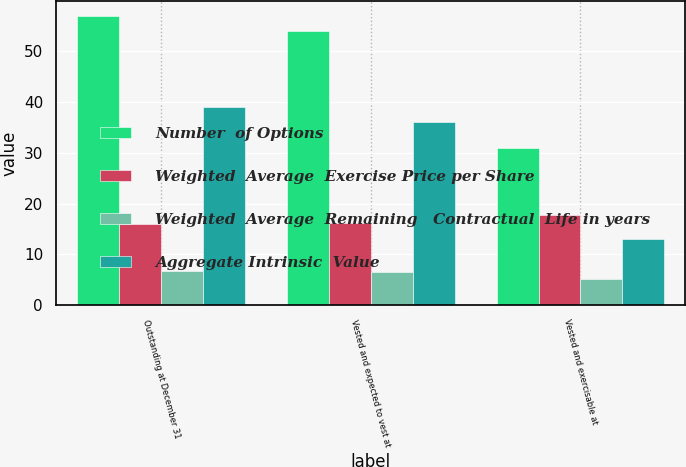<chart> <loc_0><loc_0><loc_500><loc_500><stacked_bar_chart><ecel><fcel>Outstanding at December 31<fcel>Vested and expected to vest at<fcel>Vested and exercisable at<nl><fcel>Number  of Options<fcel>57<fcel>54<fcel>31<nl><fcel>Weighted  Average  Exercise Price per Share<fcel>16.04<fcel>16.16<fcel>17.73<nl><fcel>Weighted  Average  Remaining   Contractual  Life in years<fcel>6.7<fcel>6.59<fcel>5.11<nl><fcel>Aggregate Intrinsic  Value<fcel>39<fcel>36<fcel>13<nl></chart> 